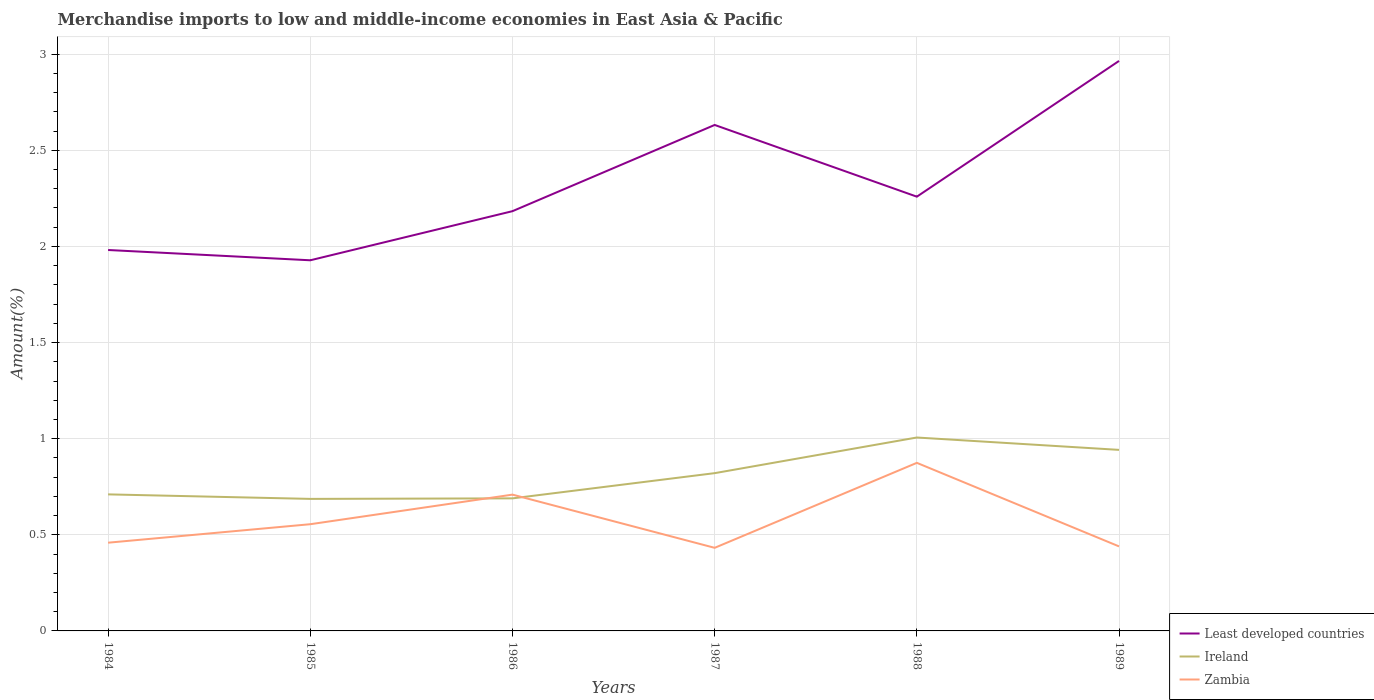Does the line corresponding to Ireland intersect with the line corresponding to Zambia?
Provide a short and direct response. Yes. Is the number of lines equal to the number of legend labels?
Keep it short and to the point. Yes. Across all years, what is the maximum percentage of amount earned from merchandise imports in Zambia?
Your answer should be very brief. 0.43. In which year was the percentage of amount earned from merchandise imports in Zambia maximum?
Give a very brief answer. 1987. What is the total percentage of amount earned from merchandise imports in Least developed countries in the graph?
Your answer should be compact. -0.28. What is the difference between the highest and the second highest percentage of amount earned from merchandise imports in Least developed countries?
Provide a succinct answer. 1.04. What is the difference between the highest and the lowest percentage of amount earned from merchandise imports in Least developed countries?
Provide a succinct answer. 2. Is the percentage of amount earned from merchandise imports in Ireland strictly greater than the percentage of amount earned from merchandise imports in Zambia over the years?
Offer a very short reply. No. How many years are there in the graph?
Your answer should be compact. 6. Are the values on the major ticks of Y-axis written in scientific E-notation?
Give a very brief answer. No. Does the graph contain any zero values?
Make the answer very short. No. Does the graph contain grids?
Offer a very short reply. Yes. Where does the legend appear in the graph?
Ensure brevity in your answer.  Bottom right. How are the legend labels stacked?
Give a very brief answer. Vertical. What is the title of the graph?
Your answer should be compact. Merchandise imports to low and middle-income economies in East Asia & Pacific. What is the label or title of the Y-axis?
Provide a succinct answer. Amount(%). What is the Amount(%) of Least developed countries in 1984?
Your response must be concise. 1.98. What is the Amount(%) in Ireland in 1984?
Offer a very short reply. 0.71. What is the Amount(%) of Zambia in 1984?
Offer a very short reply. 0.46. What is the Amount(%) in Least developed countries in 1985?
Provide a succinct answer. 1.93. What is the Amount(%) of Ireland in 1985?
Ensure brevity in your answer.  0.69. What is the Amount(%) in Zambia in 1985?
Keep it short and to the point. 0.56. What is the Amount(%) of Least developed countries in 1986?
Give a very brief answer. 2.18. What is the Amount(%) of Ireland in 1986?
Make the answer very short. 0.69. What is the Amount(%) of Zambia in 1986?
Your answer should be very brief. 0.71. What is the Amount(%) in Least developed countries in 1987?
Ensure brevity in your answer.  2.63. What is the Amount(%) of Ireland in 1987?
Provide a succinct answer. 0.82. What is the Amount(%) in Zambia in 1987?
Offer a very short reply. 0.43. What is the Amount(%) in Least developed countries in 1988?
Offer a terse response. 2.26. What is the Amount(%) of Ireland in 1988?
Provide a short and direct response. 1.01. What is the Amount(%) in Zambia in 1988?
Your answer should be compact. 0.87. What is the Amount(%) in Least developed countries in 1989?
Your answer should be compact. 2.97. What is the Amount(%) of Ireland in 1989?
Provide a succinct answer. 0.94. What is the Amount(%) of Zambia in 1989?
Provide a succinct answer. 0.44. Across all years, what is the maximum Amount(%) in Least developed countries?
Your response must be concise. 2.97. Across all years, what is the maximum Amount(%) in Ireland?
Your answer should be compact. 1.01. Across all years, what is the maximum Amount(%) of Zambia?
Give a very brief answer. 0.87. Across all years, what is the minimum Amount(%) of Least developed countries?
Your response must be concise. 1.93. Across all years, what is the minimum Amount(%) in Ireland?
Offer a terse response. 0.69. Across all years, what is the minimum Amount(%) in Zambia?
Your answer should be very brief. 0.43. What is the total Amount(%) of Least developed countries in the graph?
Provide a succinct answer. 13.95. What is the total Amount(%) of Ireland in the graph?
Provide a short and direct response. 4.86. What is the total Amount(%) in Zambia in the graph?
Give a very brief answer. 3.47. What is the difference between the Amount(%) of Least developed countries in 1984 and that in 1985?
Provide a short and direct response. 0.05. What is the difference between the Amount(%) of Ireland in 1984 and that in 1985?
Your answer should be very brief. 0.02. What is the difference between the Amount(%) in Zambia in 1984 and that in 1985?
Make the answer very short. -0.1. What is the difference between the Amount(%) of Least developed countries in 1984 and that in 1986?
Give a very brief answer. -0.2. What is the difference between the Amount(%) of Ireland in 1984 and that in 1986?
Make the answer very short. 0.02. What is the difference between the Amount(%) of Zambia in 1984 and that in 1986?
Give a very brief answer. -0.25. What is the difference between the Amount(%) of Least developed countries in 1984 and that in 1987?
Provide a short and direct response. -0.65. What is the difference between the Amount(%) in Ireland in 1984 and that in 1987?
Offer a very short reply. -0.11. What is the difference between the Amount(%) in Zambia in 1984 and that in 1987?
Your response must be concise. 0.03. What is the difference between the Amount(%) in Least developed countries in 1984 and that in 1988?
Keep it short and to the point. -0.28. What is the difference between the Amount(%) in Ireland in 1984 and that in 1988?
Your response must be concise. -0.3. What is the difference between the Amount(%) of Zambia in 1984 and that in 1988?
Provide a succinct answer. -0.42. What is the difference between the Amount(%) in Least developed countries in 1984 and that in 1989?
Your answer should be very brief. -0.98. What is the difference between the Amount(%) of Ireland in 1984 and that in 1989?
Your answer should be compact. -0.23. What is the difference between the Amount(%) of Zambia in 1984 and that in 1989?
Keep it short and to the point. 0.02. What is the difference between the Amount(%) in Least developed countries in 1985 and that in 1986?
Your answer should be very brief. -0.26. What is the difference between the Amount(%) of Ireland in 1985 and that in 1986?
Your response must be concise. -0. What is the difference between the Amount(%) in Zambia in 1985 and that in 1986?
Ensure brevity in your answer.  -0.15. What is the difference between the Amount(%) in Least developed countries in 1985 and that in 1987?
Make the answer very short. -0.7. What is the difference between the Amount(%) of Ireland in 1985 and that in 1987?
Your answer should be compact. -0.13. What is the difference between the Amount(%) in Zambia in 1985 and that in 1987?
Make the answer very short. 0.12. What is the difference between the Amount(%) of Least developed countries in 1985 and that in 1988?
Ensure brevity in your answer.  -0.33. What is the difference between the Amount(%) in Ireland in 1985 and that in 1988?
Provide a short and direct response. -0.32. What is the difference between the Amount(%) of Zambia in 1985 and that in 1988?
Your answer should be very brief. -0.32. What is the difference between the Amount(%) in Least developed countries in 1985 and that in 1989?
Make the answer very short. -1.04. What is the difference between the Amount(%) in Ireland in 1985 and that in 1989?
Offer a terse response. -0.26. What is the difference between the Amount(%) of Zambia in 1985 and that in 1989?
Ensure brevity in your answer.  0.12. What is the difference between the Amount(%) in Least developed countries in 1986 and that in 1987?
Keep it short and to the point. -0.45. What is the difference between the Amount(%) in Ireland in 1986 and that in 1987?
Keep it short and to the point. -0.13. What is the difference between the Amount(%) of Zambia in 1986 and that in 1987?
Ensure brevity in your answer.  0.28. What is the difference between the Amount(%) of Least developed countries in 1986 and that in 1988?
Provide a short and direct response. -0.08. What is the difference between the Amount(%) of Ireland in 1986 and that in 1988?
Provide a short and direct response. -0.32. What is the difference between the Amount(%) in Zambia in 1986 and that in 1988?
Provide a short and direct response. -0.17. What is the difference between the Amount(%) in Least developed countries in 1986 and that in 1989?
Provide a short and direct response. -0.78. What is the difference between the Amount(%) of Ireland in 1986 and that in 1989?
Ensure brevity in your answer.  -0.25. What is the difference between the Amount(%) of Zambia in 1986 and that in 1989?
Give a very brief answer. 0.27. What is the difference between the Amount(%) of Least developed countries in 1987 and that in 1988?
Offer a very short reply. 0.37. What is the difference between the Amount(%) of Ireland in 1987 and that in 1988?
Keep it short and to the point. -0.19. What is the difference between the Amount(%) in Zambia in 1987 and that in 1988?
Your response must be concise. -0.44. What is the difference between the Amount(%) in Least developed countries in 1987 and that in 1989?
Provide a succinct answer. -0.33. What is the difference between the Amount(%) in Ireland in 1987 and that in 1989?
Offer a terse response. -0.12. What is the difference between the Amount(%) of Zambia in 1987 and that in 1989?
Offer a terse response. -0.01. What is the difference between the Amount(%) of Least developed countries in 1988 and that in 1989?
Your answer should be very brief. -0.71. What is the difference between the Amount(%) of Ireland in 1988 and that in 1989?
Give a very brief answer. 0.06. What is the difference between the Amount(%) in Zambia in 1988 and that in 1989?
Offer a terse response. 0.43. What is the difference between the Amount(%) in Least developed countries in 1984 and the Amount(%) in Ireland in 1985?
Keep it short and to the point. 1.29. What is the difference between the Amount(%) in Least developed countries in 1984 and the Amount(%) in Zambia in 1985?
Provide a succinct answer. 1.43. What is the difference between the Amount(%) in Ireland in 1984 and the Amount(%) in Zambia in 1985?
Provide a succinct answer. 0.16. What is the difference between the Amount(%) in Least developed countries in 1984 and the Amount(%) in Ireland in 1986?
Ensure brevity in your answer.  1.29. What is the difference between the Amount(%) of Least developed countries in 1984 and the Amount(%) of Zambia in 1986?
Provide a short and direct response. 1.27. What is the difference between the Amount(%) in Ireland in 1984 and the Amount(%) in Zambia in 1986?
Provide a short and direct response. 0. What is the difference between the Amount(%) in Least developed countries in 1984 and the Amount(%) in Ireland in 1987?
Your answer should be compact. 1.16. What is the difference between the Amount(%) of Least developed countries in 1984 and the Amount(%) of Zambia in 1987?
Keep it short and to the point. 1.55. What is the difference between the Amount(%) in Ireland in 1984 and the Amount(%) in Zambia in 1987?
Provide a short and direct response. 0.28. What is the difference between the Amount(%) in Least developed countries in 1984 and the Amount(%) in Ireland in 1988?
Your response must be concise. 0.98. What is the difference between the Amount(%) of Least developed countries in 1984 and the Amount(%) of Zambia in 1988?
Provide a short and direct response. 1.11. What is the difference between the Amount(%) in Ireland in 1984 and the Amount(%) in Zambia in 1988?
Offer a terse response. -0.16. What is the difference between the Amount(%) in Least developed countries in 1984 and the Amount(%) in Ireland in 1989?
Offer a terse response. 1.04. What is the difference between the Amount(%) in Least developed countries in 1984 and the Amount(%) in Zambia in 1989?
Provide a succinct answer. 1.54. What is the difference between the Amount(%) of Ireland in 1984 and the Amount(%) of Zambia in 1989?
Your answer should be compact. 0.27. What is the difference between the Amount(%) in Least developed countries in 1985 and the Amount(%) in Ireland in 1986?
Your response must be concise. 1.24. What is the difference between the Amount(%) in Least developed countries in 1985 and the Amount(%) in Zambia in 1986?
Provide a succinct answer. 1.22. What is the difference between the Amount(%) of Ireland in 1985 and the Amount(%) of Zambia in 1986?
Keep it short and to the point. -0.02. What is the difference between the Amount(%) of Least developed countries in 1985 and the Amount(%) of Ireland in 1987?
Your answer should be very brief. 1.11. What is the difference between the Amount(%) in Least developed countries in 1985 and the Amount(%) in Zambia in 1987?
Your answer should be very brief. 1.5. What is the difference between the Amount(%) in Ireland in 1985 and the Amount(%) in Zambia in 1987?
Offer a terse response. 0.25. What is the difference between the Amount(%) of Least developed countries in 1985 and the Amount(%) of Ireland in 1988?
Provide a short and direct response. 0.92. What is the difference between the Amount(%) in Least developed countries in 1985 and the Amount(%) in Zambia in 1988?
Provide a succinct answer. 1.05. What is the difference between the Amount(%) in Ireland in 1985 and the Amount(%) in Zambia in 1988?
Offer a terse response. -0.19. What is the difference between the Amount(%) in Least developed countries in 1985 and the Amount(%) in Ireland in 1989?
Keep it short and to the point. 0.99. What is the difference between the Amount(%) of Least developed countries in 1985 and the Amount(%) of Zambia in 1989?
Ensure brevity in your answer.  1.49. What is the difference between the Amount(%) of Ireland in 1985 and the Amount(%) of Zambia in 1989?
Ensure brevity in your answer.  0.25. What is the difference between the Amount(%) in Least developed countries in 1986 and the Amount(%) in Ireland in 1987?
Your answer should be compact. 1.36. What is the difference between the Amount(%) in Least developed countries in 1986 and the Amount(%) in Zambia in 1987?
Ensure brevity in your answer.  1.75. What is the difference between the Amount(%) in Ireland in 1986 and the Amount(%) in Zambia in 1987?
Provide a short and direct response. 0.26. What is the difference between the Amount(%) of Least developed countries in 1986 and the Amount(%) of Ireland in 1988?
Your response must be concise. 1.18. What is the difference between the Amount(%) of Least developed countries in 1986 and the Amount(%) of Zambia in 1988?
Give a very brief answer. 1.31. What is the difference between the Amount(%) of Ireland in 1986 and the Amount(%) of Zambia in 1988?
Your answer should be very brief. -0.18. What is the difference between the Amount(%) of Least developed countries in 1986 and the Amount(%) of Ireland in 1989?
Your answer should be compact. 1.24. What is the difference between the Amount(%) of Least developed countries in 1986 and the Amount(%) of Zambia in 1989?
Offer a very short reply. 1.74. What is the difference between the Amount(%) of Ireland in 1986 and the Amount(%) of Zambia in 1989?
Your answer should be very brief. 0.25. What is the difference between the Amount(%) in Least developed countries in 1987 and the Amount(%) in Ireland in 1988?
Your response must be concise. 1.63. What is the difference between the Amount(%) of Least developed countries in 1987 and the Amount(%) of Zambia in 1988?
Your answer should be very brief. 1.76. What is the difference between the Amount(%) of Ireland in 1987 and the Amount(%) of Zambia in 1988?
Your answer should be very brief. -0.05. What is the difference between the Amount(%) in Least developed countries in 1987 and the Amount(%) in Ireland in 1989?
Your answer should be compact. 1.69. What is the difference between the Amount(%) in Least developed countries in 1987 and the Amount(%) in Zambia in 1989?
Give a very brief answer. 2.19. What is the difference between the Amount(%) in Ireland in 1987 and the Amount(%) in Zambia in 1989?
Your answer should be compact. 0.38. What is the difference between the Amount(%) of Least developed countries in 1988 and the Amount(%) of Ireland in 1989?
Give a very brief answer. 1.32. What is the difference between the Amount(%) of Least developed countries in 1988 and the Amount(%) of Zambia in 1989?
Ensure brevity in your answer.  1.82. What is the difference between the Amount(%) of Ireland in 1988 and the Amount(%) of Zambia in 1989?
Keep it short and to the point. 0.57. What is the average Amount(%) in Least developed countries per year?
Provide a succinct answer. 2.32. What is the average Amount(%) of Ireland per year?
Your answer should be compact. 0.81. What is the average Amount(%) in Zambia per year?
Give a very brief answer. 0.58. In the year 1984, what is the difference between the Amount(%) in Least developed countries and Amount(%) in Ireland?
Provide a short and direct response. 1.27. In the year 1984, what is the difference between the Amount(%) of Least developed countries and Amount(%) of Zambia?
Give a very brief answer. 1.52. In the year 1984, what is the difference between the Amount(%) of Ireland and Amount(%) of Zambia?
Ensure brevity in your answer.  0.25. In the year 1985, what is the difference between the Amount(%) of Least developed countries and Amount(%) of Ireland?
Provide a short and direct response. 1.24. In the year 1985, what is the difference between the Amount(%) of Least developed countries and Amount(%) of Zambia?
Give a very brief answer. 1.37. In the year 1985, what is the difference between the Amount(%) in Ireland and Amount(%) in Zambia?
Give a very brief answer. 0.13. In the year 1986, what is the difference between the Amount(%) of Least developed countries and Amount(%) of Ireland?
Make the answer very short. 1.49. In the year 1986, what is the difference between the Amount(%) of Least developed countries and Amount(%) of Zambia?
Provide a short and direct response. 1.47. In the year 1986, what is the difference between the Amount(%) in Ireland and Amount(%) in Zambia?
Keep it short and to the point. -0.02. In the year 1987, what is the difference between the Amount(%) in Least developed countries and Amount(%) in Ireland?
Give a very brief answer. 1.81. In the year 1987, what is the difference between the Amount(%) in Least developed countries and Amount(%) in Zambia?
Provide a succinct answer. 2.2. In the year 1987, what is the difference between the Amount(%) of Ireland and Amount(%) of Zambia?
Make the answer very short. 0.39. In the year 1988, what is the difference between the Amount(%) of Least developed countries and Amount(%) of Ireland?
Your response must be concise. 1.25. In the year 1988, what is the difference between the Amount(%) of Least developed countries and Amount(%) of Zambia?
Keep it short and to the point. 1.38. In the year 1988, what is the difference between the Amount(%) in Ireland and Amount(%) in Zambia?
Ensure brevity in your answer.  0.13. In the year 1989, what is the difference between the Amount(%) in Least developed countries and Amount(%) in Ireland?
Offer a terse response. 2.02. In the year 1989, what is the difference between the Amount(%) of Least developed countries and Amount(%) of Zambia?
Your answer should be compact. 2.53. In the year 1989, what is the difference between the Amount(%) in Ireland and Amount(%) in Zambia?
Provide a succinct answer. 0.5. What is the ratio of the Amount(%) in Least developed countries in 1984 to that in 1985?
Provide a succinct answer. 1.03. What is the ratio of the Amount(%) of Ireland in 1984 to that in 1985?
Provide a short and direct response. 1.03. What is the ratio of the Amount(%) in Zambia in 1984 to that in 1985?
Give a very brief answer. 0.83. What is the ratio of the Amount(%) in Least developed countries in 1984 to that in 1986?
Keep it short and to the point. 0.91. What is the ratio of the Amount(%) of Ireland in 1984 to that in 1986?
Make the answer very short. 1.03. What is the ratio of the Amount(%) in Zambia in 1984 to that in 1986?
Your answer should be compact. 0.65. What is the ratio of the Amount(%) in Least developed countries in 1984 to that in 1987?
Ensure brevity in your answer.  0.75. What is the ratio of the Amount(%) of Ireland in 1984 to that in 1987?
Offer a very short reply. 0.87. What is the ratio of the Amount(%) of Zambia in 1984 to that in 1987?
Provide a short and direct response. 1.06. What is the ratio of the Amount(%) of Least developed countries in 1984 to that in 1988?
Give a very brief answer. 0.88. What is the ratio of the Amount(%) in Ireland in 1984 to that in 1988?
Keep it short and to the point. 0.71. What is the ratio of the Amount(%) in Zambia in 1984 to that in 1988?
Keep it short and to the point. 0.52. What is the ratio of the Amount(%) of Least developed countries in 1984 to that in 1989?
Offer a very short reply. 0.67. What is the ratio of the Amount(%) of Ireland in 1984 to that in 1989?
Ensure brevity in your answer.  0.75. What is the ratio of the Amount(%) of Zambia in 1984 to that in 1989?
Your response must be concise. 1.04. What is the ratio of the Amount(%) in Least developed countries in 1985 to that in 1986?
Offer a terse response. 0.88. What is the ratio of the Amount(%) in Zambia in 1985 to that in 1986?
Ensure brevity in your answer.  0.78. What is the ratio of the Amount(%) of Least developed countries in 1985 to that in 1987?
Make the answer very short. 0.73. What is the ratio of the Amount(%) in Ireland in 1985 to that in 1987?
Your response must be concise. 0.84. What is the ratio of the Amount(%) of Zambia in 1985 to that in 1987?
Ensure brevity in your answer.  1.28. What is the ratio of the Amount(%) of Least developed countries in 1985 to that in 1988?
Ensure brevity in your answer.  0.85. What is the ratio of the Amount(%) of Ireland in 1985 to that in 1988?
Make the answer very short. 0.68. What is the ratio of the Amount(%) in Zambia in 1985 to that in 1988?
Provide a short and direct response. 0.63. What is the ratio of the Amount(%) of Least developed countries in 1985 to that in 1989?
Provide a succinct answer. 0.65. What is the ratio of the Amount(%) in Ireland in 1985 to that in 1989?
Your response must be concise. 0.73. What is the ratio of the Amount(%) of Zambia in 1985 to that in 1989?
Your response must be concise. 1.26. What is the ratio of the Amount(%) in Least developed countries in 1986 to that in 1987?
Keep it short and to the point. 0.83. What is the ratio of the Amount(%) in Ireland in 1986 to that in 1987?
Give a very brief answer. 0.84. What is the ratio of the Amount(%) in Zambia in 1986 to that in 1987?
Offer a terse response. 1.64. What is the ratio of the Amount(%) in Least developed countries in 1986 to that in 1988?
Your response must be concise. 0.97. What is the ratio of the Amount(%) in Ireland in 1986 to that in 1988?
Provide a short and direct response. 0.69. What is the ratio of the Amount(%) of Zambia in 1986 to that in 1988?
Your answer should be compact. 0.81. What is the ratio of the Amount(%) in Least developed countries in 1986 to that in 1989?
Make the answer very short. 0.74. What is the ratio of the Amount(%) in Ireland in 1986 to that in 1989?
Ensure brevity in your answer.  0.73. What is the ratio of the Amount(%) of Zambia in 1986 to that in 1989?
Keep it short and to the point. 1.61. What is the ratio of the Amount(%) in Least developed countries in 1987 to that in 1988?
Your response must be concise. 1.17. What is the ratio of the Amount(%) of Ireland in 1987 to that in 1988?
Offer a terse response. 0.82. What is the ratio of the Amount(%) in Zambia in 1987 to that in 1988?
Your answer should be very brief. 0.49. What is the ratio of the Amount(%) in Least developed countries in 1987 to that in 1989?
Make the answer very short. 0.89. What is the ratio of the Amount(%) of Ireland in 1987 to that in 1989?
Offer a terse response. 0.87. What is the ratio of the Amount(%) in Zambia in 1987 to that in 1989?
Your answer should be compact. 0.98. What is the ratio of the Amount(%) in Least developed countries in 1988 to that in 1989?
Your response must be concise. 0.76. What is the ratio of the Amount(%) of Ireland in 1988 to that in 1989?
Provide a short and direct response. 1.07. What is the ratio of the Amount(%) of Zambia in 1988 to that in 1989?
Your response must be concise. 1.99. What is the difference between the highest and the second highest Amount(%) in Least developed countries?
Your answer should be very brief. 0.33. What is the difference between the highest and the second highest Amount(%) of Ireland?
Ensure brevity in your answer.  0.06. What is the difference between the highest and the second highest Amount(%) in Zambia?
Ensure brevity in your answer.  0.17. What is the difference between the highest and the lowest Amount(%) of Least developed countries?
Ensure brevity in your answer.  1.04. What is the difference between the highest and the lowest Amount(%) in Ireland?
Keep it short and to the point. 0.32. What is the difference between the highest and the lowest Amount(%) of Zambia?
Provide a short and direct response. 0.44. 